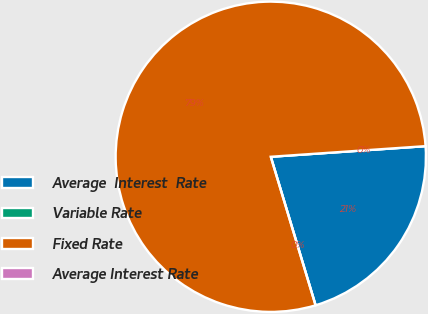Convert chart to OTSL. <chart><loc_0><loc_0><loc_500><loc_500><pie_chart><fcel>Average  Interest  Rate<fcel>Variable Rate<fcel>Fixed Rate<fcel>Average Interest Rate<nl><fcel>21.43%<fcel>0.0%<fcel>78.57%<fcel>0.0%<nl></chart> 